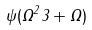<formula> <loc_0><loc_0><loc_500><loc_500>\psi ( \Omega ^ { 2 } 3 + \Omega )</formula> 